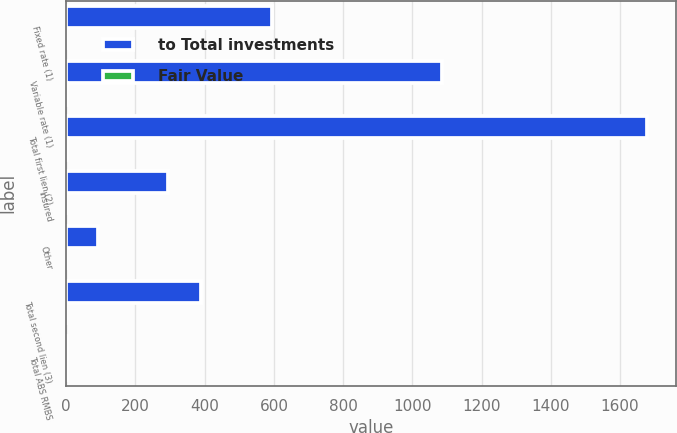<chart> <loc_0><loc_0><loc_500><loc_500><stacked_bar_chart><ecel><fcel>Fixed rate (1)<fcel>Variable rate (1)<fcel>Total first lien (2)<fcel>Insured<fcel>Other<fcel>Total second lien (3)<fcel>Total ABS RMBS<nl><fcel>to Total investments<fcel>594<fcel>1085<fcel>1679<fcel>295<fcel>93<fcel>388<fcel>2.1<nl><fcel>Fair Value<fcel>0.6<fcel>1.1<fcel>1.7<fcel>0.3<fcel>0.1<fcel>0.4<fcel>2.1<nl></chart> 